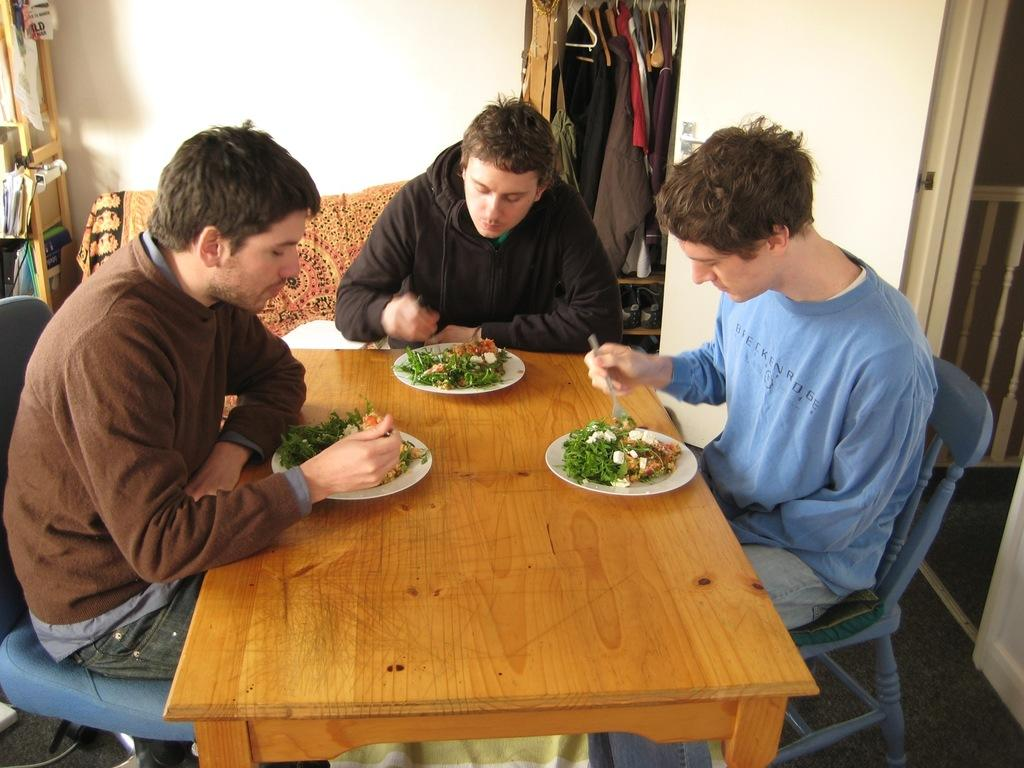What is the person in the image holding? The person in the image is holding a cup of coffee. What is the person's seating arrangement in the image? The person is sitting on a sofa. How many babies are swimming in the cup of coffee in the image? There are no babies present in the image, and the cup of coffee is not depicted as containing any liquid. 